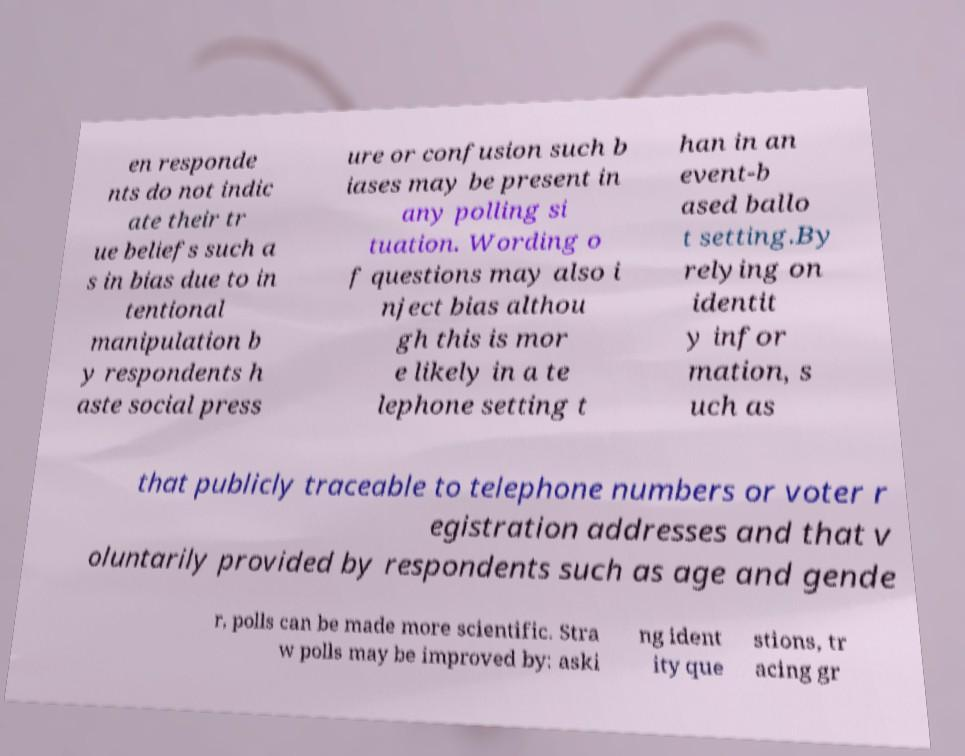I need the written content from this picture converted into text. Can you do that? en responde nts do not indic ate their tr ue beliefs such a s in bias due to in tentional manipulation b y respondents h aste social press ure or confusion such b iases may be present in any polling si tuation. Wording o f questions may also i nject bias althou gh this is mor e likely in a te lephone setting t han in an event-b ased ballo t setting.By relying on identit y infor mation, s uch as that publicly traceable to telephone numbers or voter r egistration addresses and that v oluntarily provided by respondents such as age and gende r, polls can be made more scientific. Stra w polls may be improved by: aski ng ident ity que stions, tr acing gr 